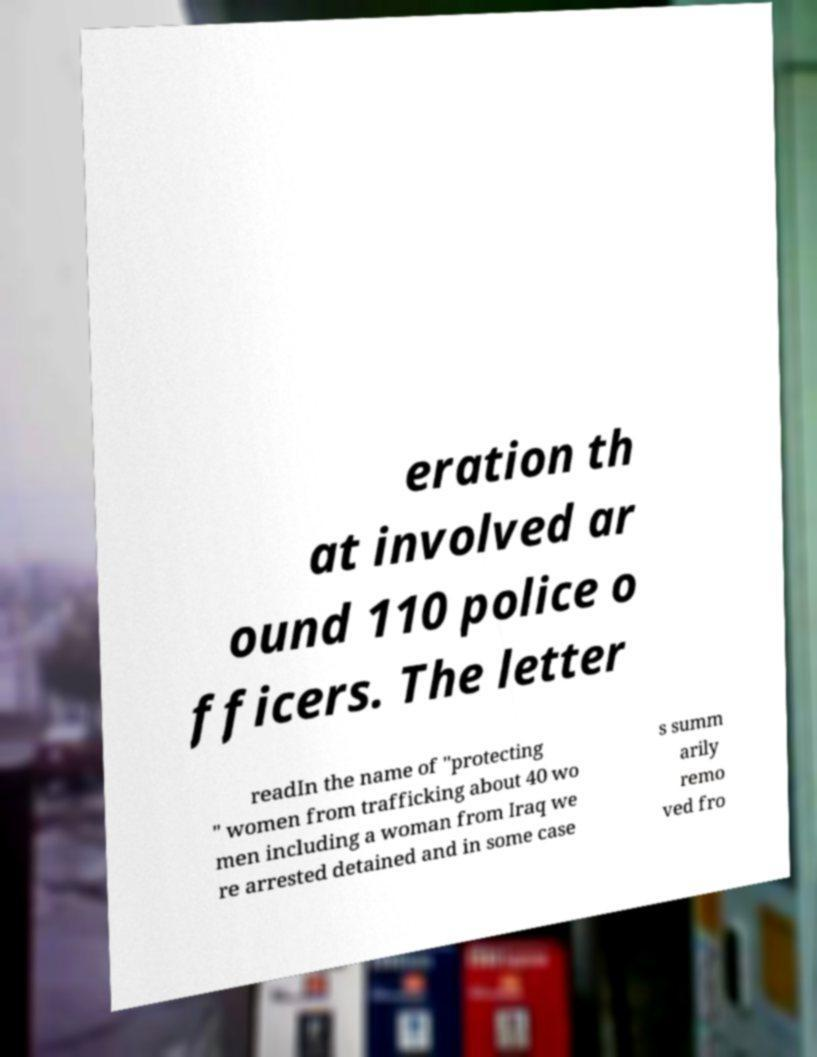There's text embedded in this image that I need extracted. Can you transcribe it verbatim? eration th at involved ar ound 110 police o fficers. The letter readIn the name of "protecting " women from trafficking about 40 wo men including a woman from Iraq we re arrested detained and in some case s summ arily remo ved fro 